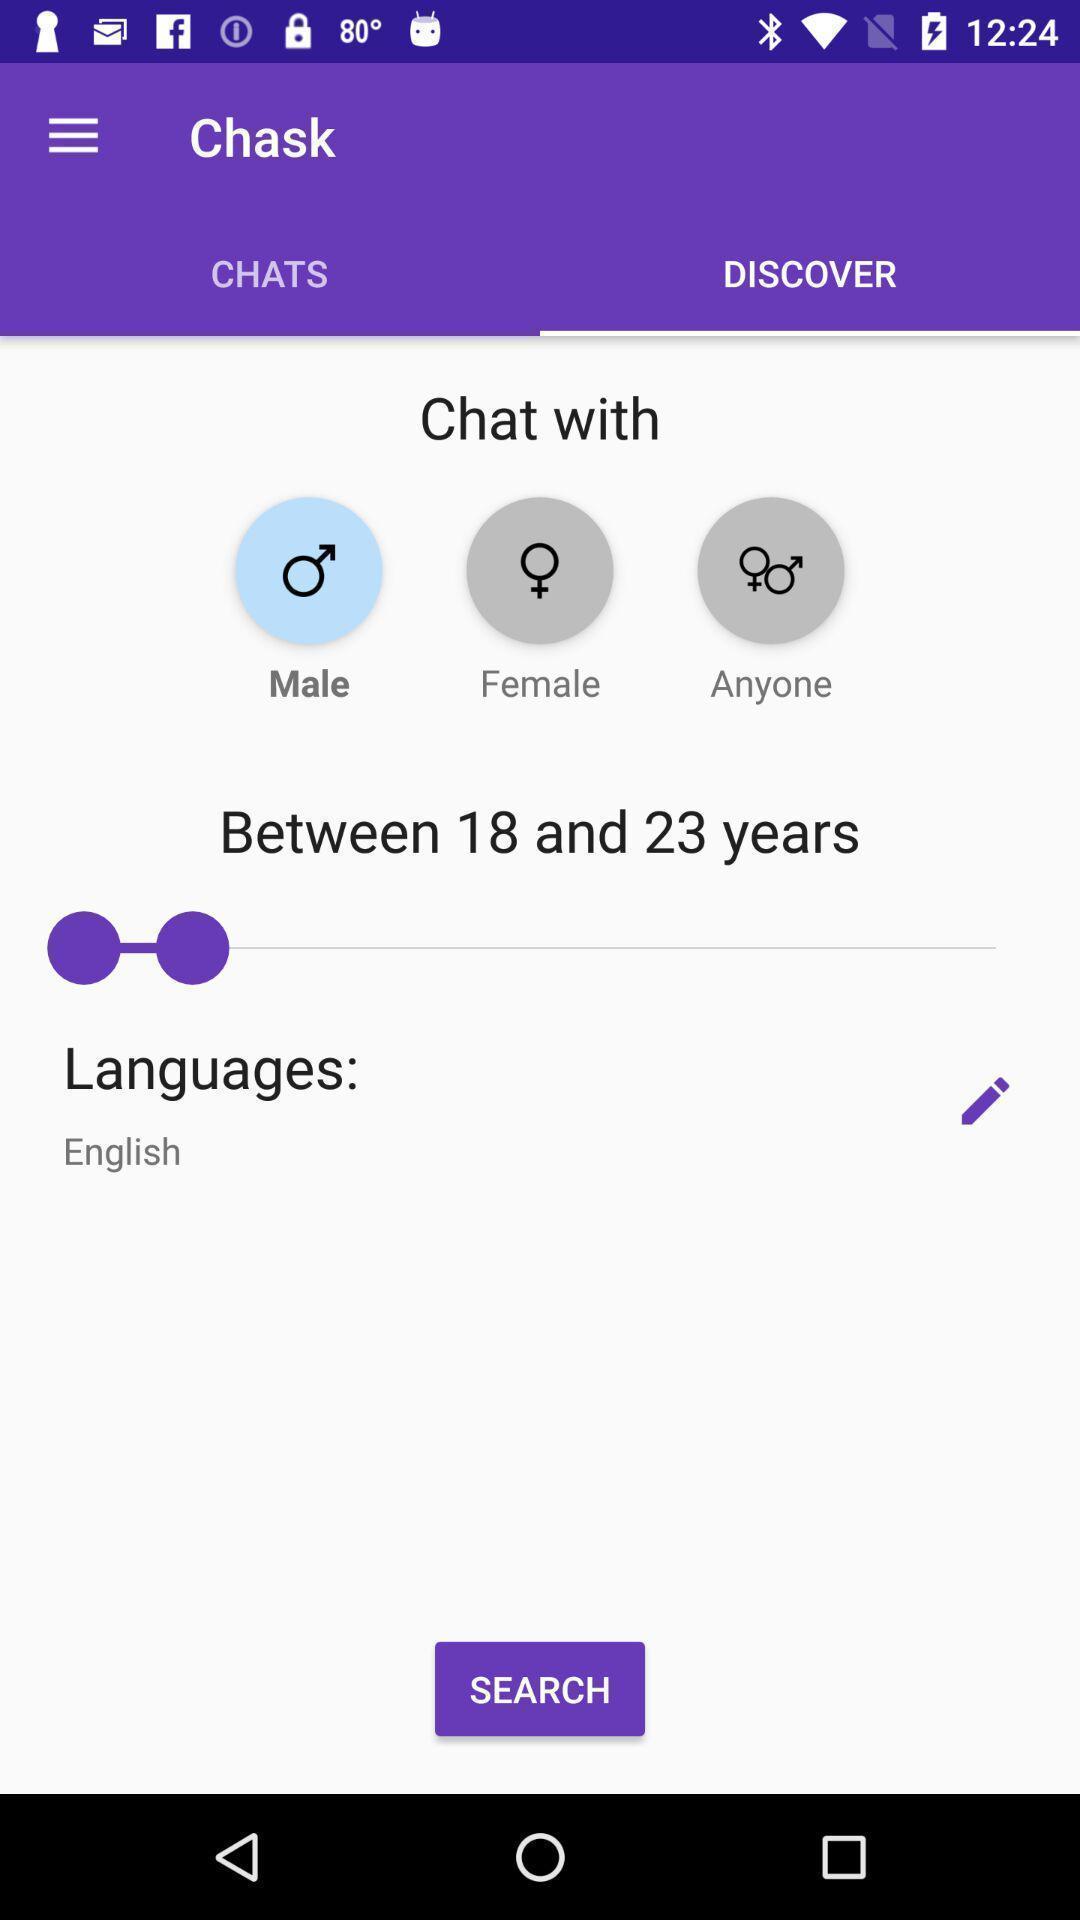Provide a detailed account of this screenshot. Page showing preferences to discover people. 